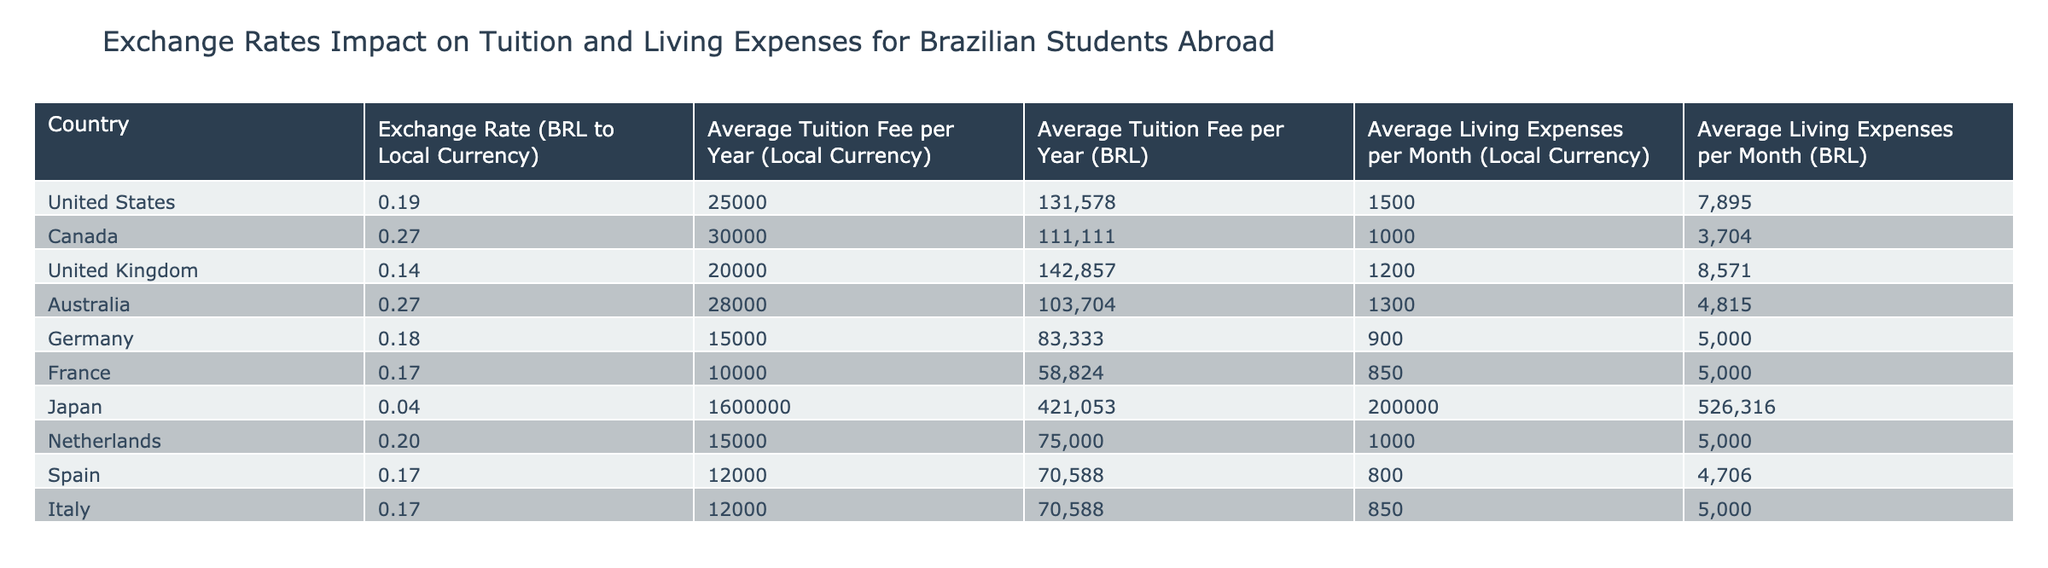What is the average tuition fee in BRL for students in Germany? The average tuition fee per year in Germany is listed as 83333 BRL.
Answer: 83333 BRL Which country has the highest living expenses per month in BRL? By reviewing the living expenses per month column in BRL, Japan shows the highest value at 526316 BRL.
Answer: Japan What is the total tuition cost required for a student in Canada over four years? The average tuition fee per year in Canada is 111111 BRL. Therefore, over four years, the total cost would be 111111 * 4 = 444444 BRL.
Answer: 444444 BRL Is the average monthly living expense higher in the United States than in Australia? The average monthly living expense in the United States is 7895 BRL, while in Australia it is 4815 BRL. Since 7895 is greater than 4815, the statement is true.
Answer: Yes What is the difference in average tuition fees between the United States and the United Kingdom in BRL? The average tuition fee in the United States is 131578 BRL, and in the United Kingdom, it is 142857 BRL. The difference is 142857 - 131578 = 12279 BRL.
Answer: 12279 BRL Which two countries have the same average tuition fee in BRL and what is that fee? By examining the tuition fee data, we see that Spain and Italy both have an average tuition fee of 70588 BRL.
Answer: Spain and Italy, 70588 BRL What is the average living expense per month in BRL across all countries listed? To find the average living expense per month, we add up all the monthly expenses in BRL: (7895 + 3704 + 8571 + 4815 + 5000 + 5000 + 526316 + 5000 + 4706 + 5000) = 537132. Then we divide this total by the number of countries (10), resulting in 537132 / 10 = 53713.2 BRL.
Answer: 53713.2 BRL Is the average living expense in France lower than in Germany? In France, the average living expense per month is 5000 BRL, while in Germany it is also 5000 BRL. They are equal, so the statement is false.
Answer: No 